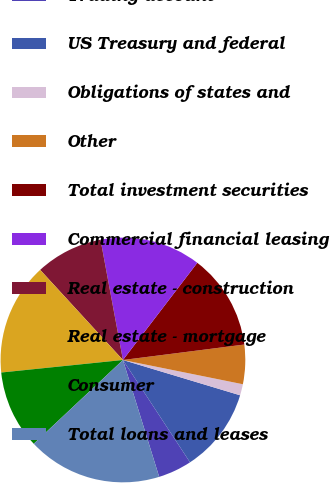Convert chart to OTSL. <chart><loc_0><loc_0><loc_500><loc_500><pie_chart><fcel>Trading account<fcel>US Treasury and federal<fcel>Obligations of states and<fcel>Other<fcel>Total investment securities<fcel>Commercial financial leasing<fcel>Real estate - construction<fcel>Real estate - mortgage<fcel>Consumer<fcel>Total loans and leases<nl><fcel>4.45%<fcel>11.11%<fcel>1.48%<fcel>5.19%<fcel>12.59%<fcel>13.33%<fcel>8.89%<fcel>14.81%<fcel>10.37%<fcel>17.78%<nl></chart> 